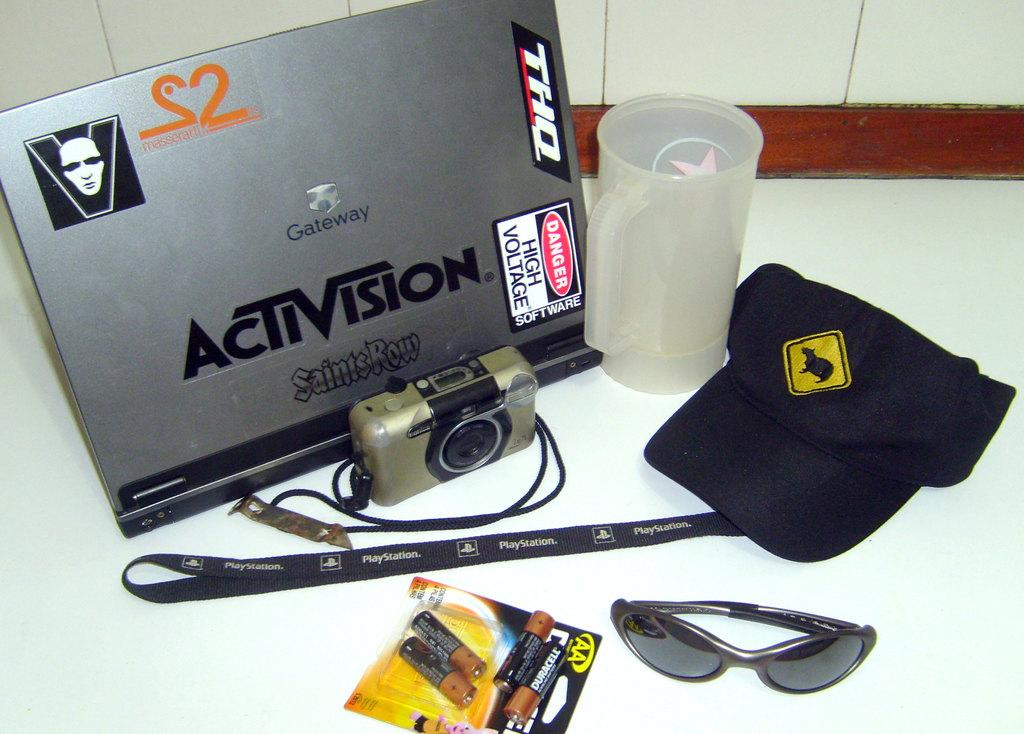What piece of furniture is present in the image? There is a table in the image. What electronic device is on the table? There is a laptop on the table. What other object related to photography is on the table? There is a camera on the table. What type of small, portable power source is on the table? There are batteries on the table. What type of clothing accessory is on the table? There is a cap on the table. What type of container for holding liquids is on the table? There is a cup on the table. What type of fowl is present in the image? There is no fowl present in the image; the objects mentioned are a table, laptop, camera, batteries, cap, and cup. 